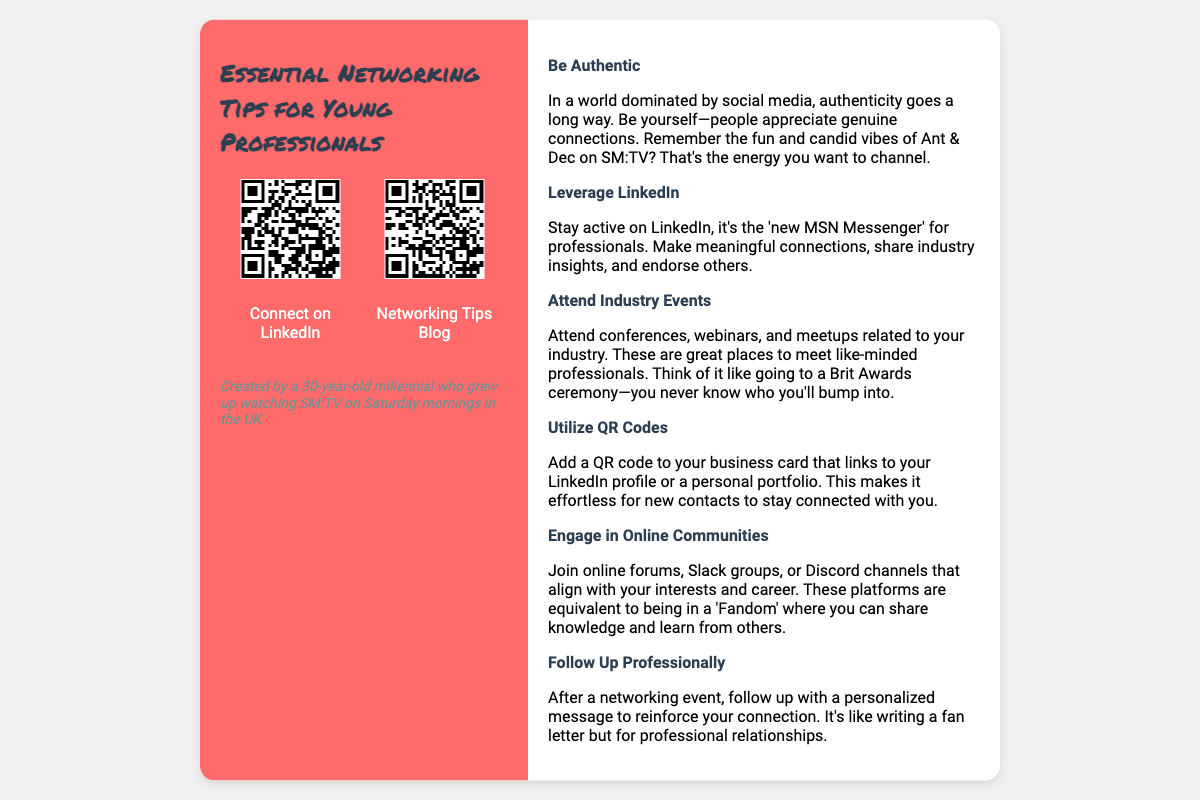What is the main title of the business card? The main title is prominently displayed at the top of the left panel of the card.
Answer: Essential Networking Tips for Young Professionals How many tips are listed on the card? The card contains a total of six different networking tips outlined in the right panel.
Answer: Six What color is the left panel of the card? The left panel has a specific color to enhance its appearance and contrast with the right panel.
Answer: Red What social media platform is specifically mentioned for networking? The document suggests a particular platform as vital for connecting with professionals, which is widely recognized in the industry.
Answer: LinkedIn What is compared to the Brit Awards in the document? The comparison is made to highlight the importance of the networking settings mentioned in the text, referring to informal gatherings.
Answer: Industry Events What should you add to your business card for better connections? The document recommends a specific technology that helps in sharing information easily with new contacts.
Answer: QR Code What style of communication is encouraged after networking events? The document emphasizes a specific personal touch that should be taken seriously in follow-ups with new contacts.
Answer: Personalized message Who created the business card? The description at the bottom of the left panel indicates the creator's demographic background and past influence.
Answer: A 30-year-old millennial 